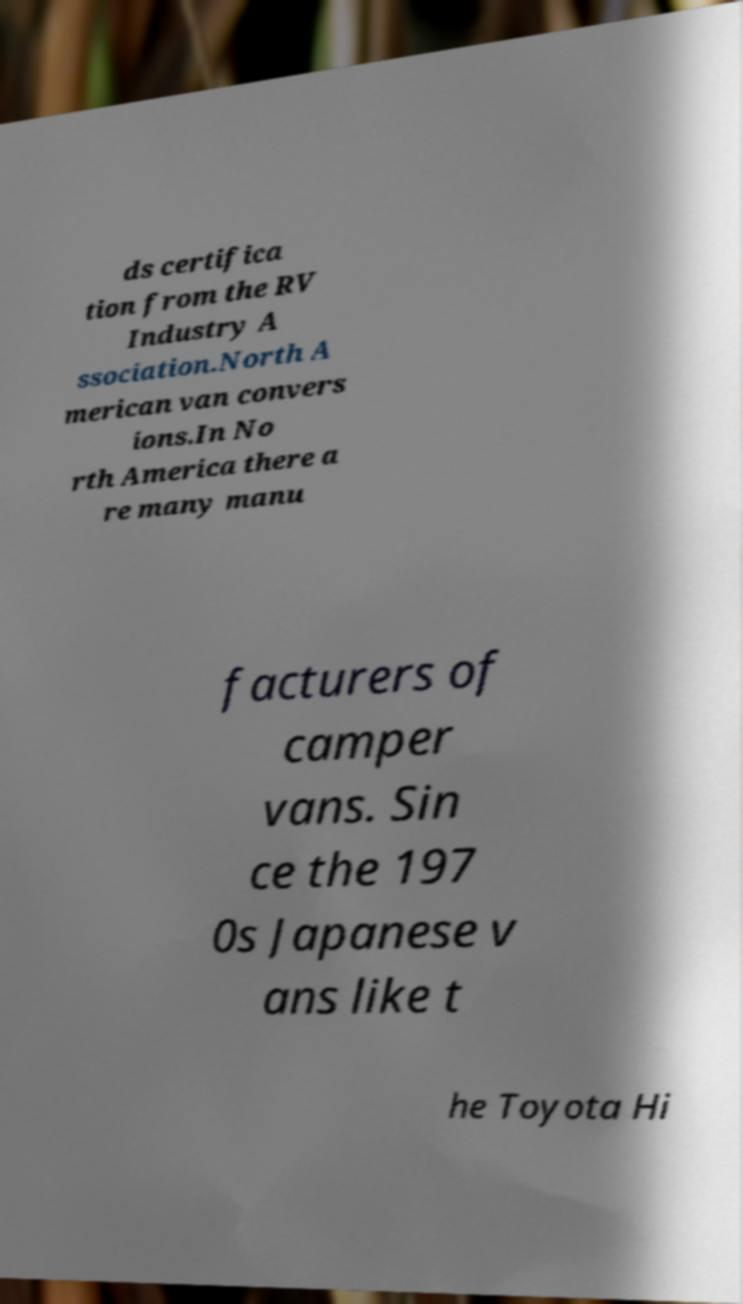I need the written content from this picture converted into text. Can you do that? ds certifica tion from the RV Industry A ssociation.North A merican van convers ions.In No rth America there a re many manu facturers of camper vans. Sin ce the 197 0s Japanese v ans like t he Toyota Hi 